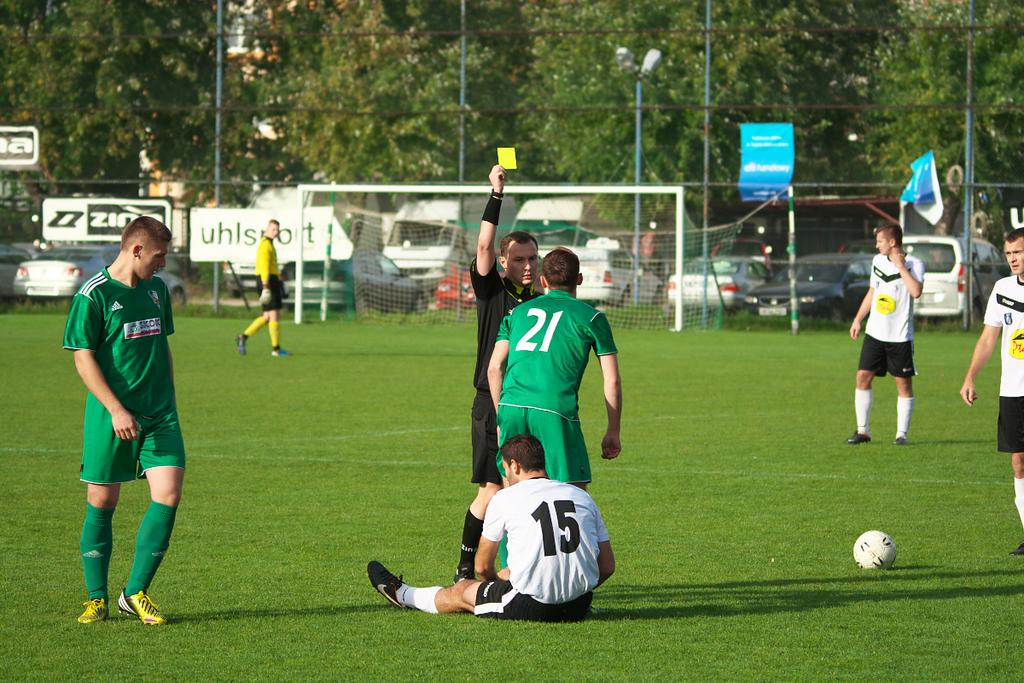<image>
Relay a brief, clear account of the picture shown. Soccer players on field with number 15 on the ground and a referee issuing a yellow card to number 21 